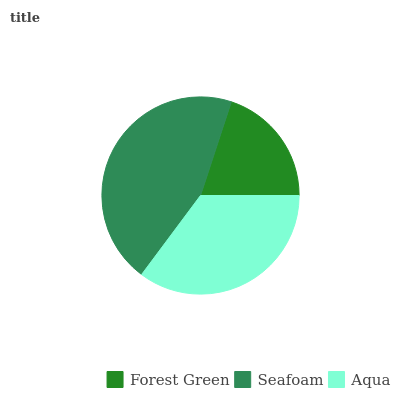Is Forest Green the minimum?
Answer yes or no. Yes. Is Seafoam the maximum?
Answer yes or no. Yes. Is Aqua the minimum?
Answer yes or no. No. Is Aqua the maximum?
Answer yes or no. No. Is Seafoam greater than Aqua?
Answer yes or no. Yes. Is Aqua less than Seafoam?
Answer yes or no. Yes. Is Aqua greater than Seafoam?
Answer yes or no. No. Is Seafoam less than Aqua?
Answer yes or no. No. Is Aqua the high median?
Answer yes or no. Yes. Is Aqua the low median?
Answer yes or no. Yes. Is Seafoam the high median?
Answer yes or no. No. Is Seafoam the low median?
Answer yes or no. No. 